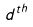<formula> <loc_0><loc_0><loc_500><loc_500>d ^ { t h }</formula> 